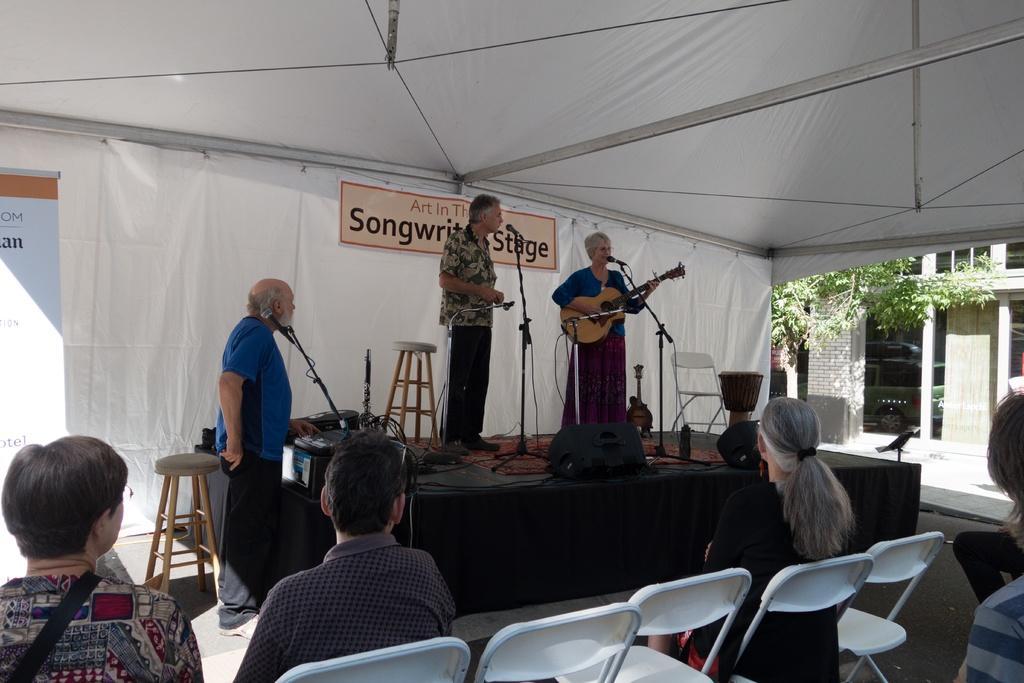Could you give a brief overview of what you see in this image? Here we can see a person is standing on the stage , and at beside a woman is standing and playing the guitar and singing, and in front here is the microphone, and stand and here are some objects,and here the group of people are sitting on the chair, and here is the tree. 